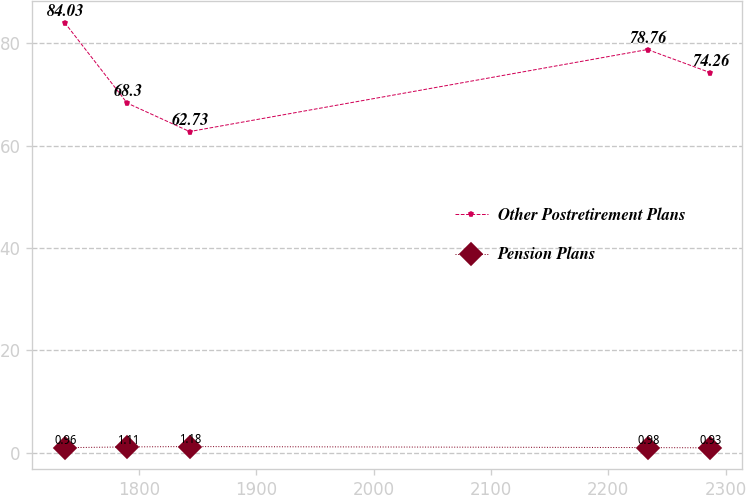Convert chart to OTSL. <chart><loc_0><loc_0><loc_500><loc_500><line_chart><ecel><fcel>Other Postretirement Plans<fcel>Pension Plans<nl><fcel>1736.78<fcel>84.03<fcel>0.96<nl><fcel>1790.02<fcel>68.3<fcel>1.11<nl><fcel>1843.26<fcel>62.73<fcel>1.18<nl><fcel>2233.38<fcel>78.76<fcel>0.98<nl><fcel>2286.62<fcel>74.26<fcel>0.93<nl></chart> 